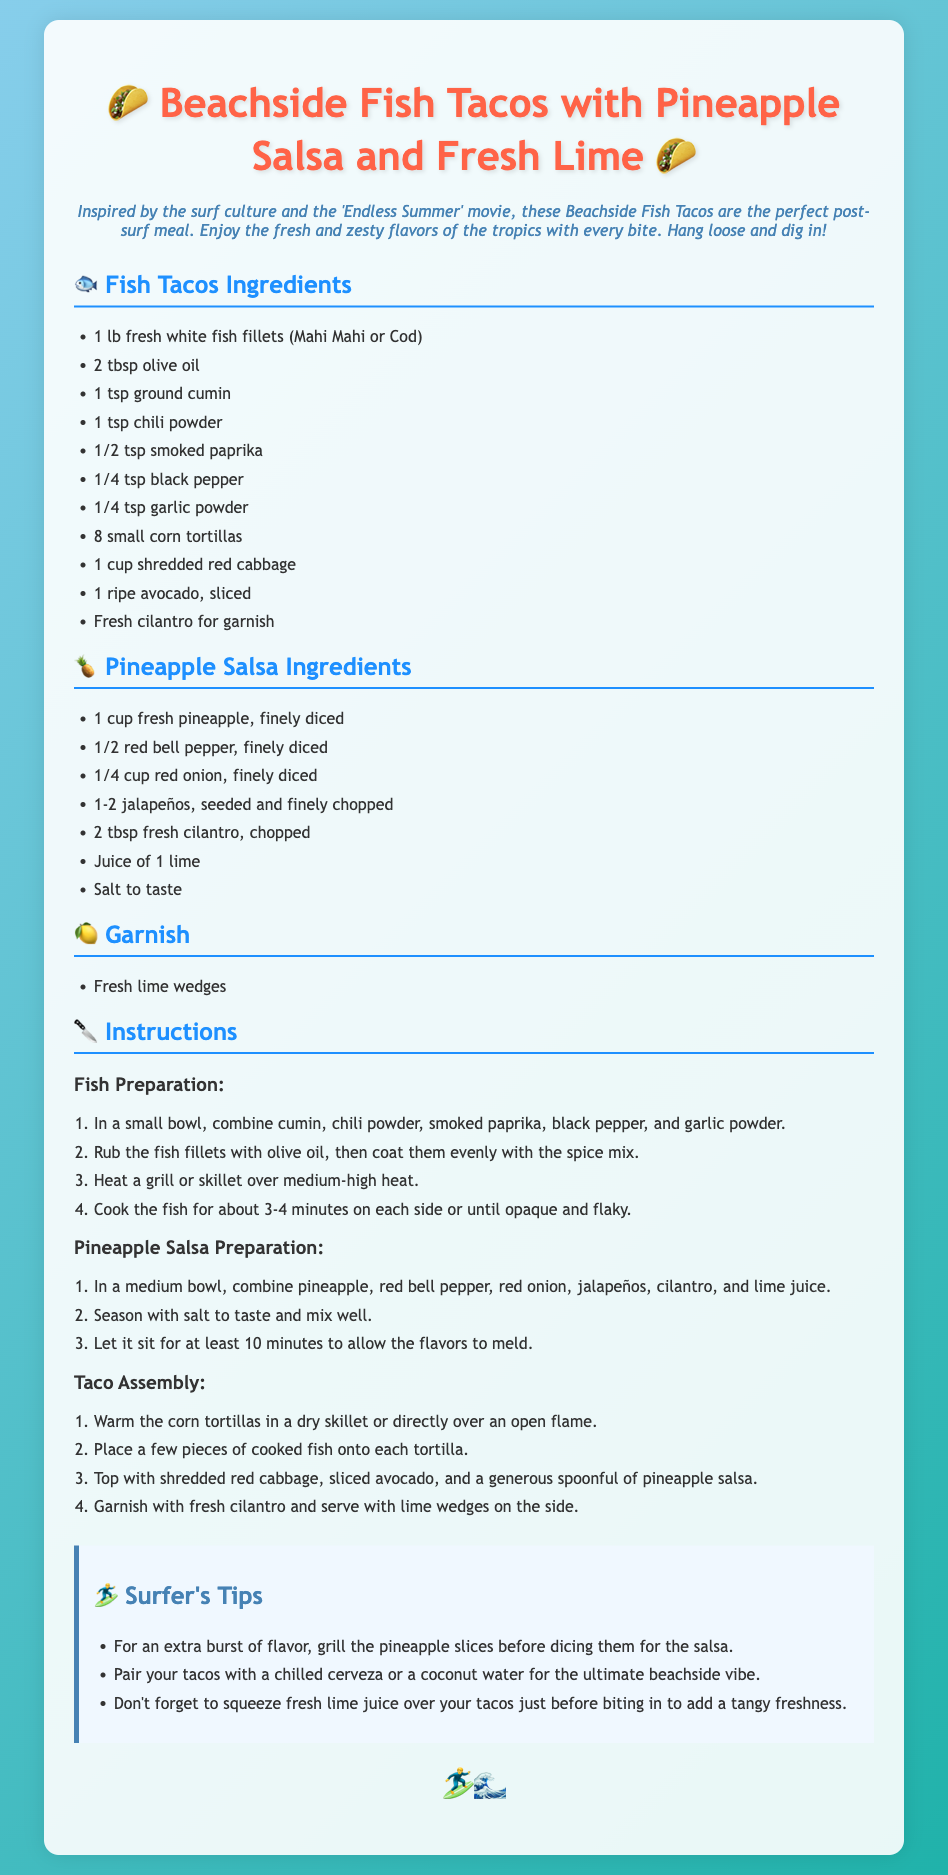What are the main ingredients for the fish tacos? The main ingredients for the fish tacos are listed in the document under the Fish Tacos Ingredients section, which includes fresh fish, olive oil, and various spices.
Answer: 1 lb fresh white fish fillets, 2 tbsp olive oil, various spices What type of fish can be used? The document specifies that Mahi Mahi or Cod can be used for the fish tacos.
Answer: Mahi Mahi or Cod How long should the fish be cooked? The instructions state that the fish should be cooked for about 3-4 minutes on each side.
Answer: 3-4 minutes What is included in the Pineapple Salsa? The Pineapple Salsa Ingredients section lists various components including fresh pineapple, red bell pepper, and more.
Answer: 1 cup fresh pineapple, 1/2 red bell pepper, 1/4 cup red onion, etc What is suggested to drink with the tacos? The tips section includes suggestions for pairing drinks with the tacos, specifically a chilled cerveza or coconut water.
Answer: Chilled cerveza or coconut water How long should the salsa sit before serving? The Pineapple Salsa Preparation section indicates that the salsa should sit for at least 10 minutes.
Answer: At least 10 minutes What is the garnish for the tacos? The Garnish section lists the fresh lime wedges as the garnish to be served with the tacos.
Answer: Fresh lime wedges What type of document is this? The overall structure and content indicate this is a recipe card for a cooking recipe related to fish tacos.
Answer: Recipe card 